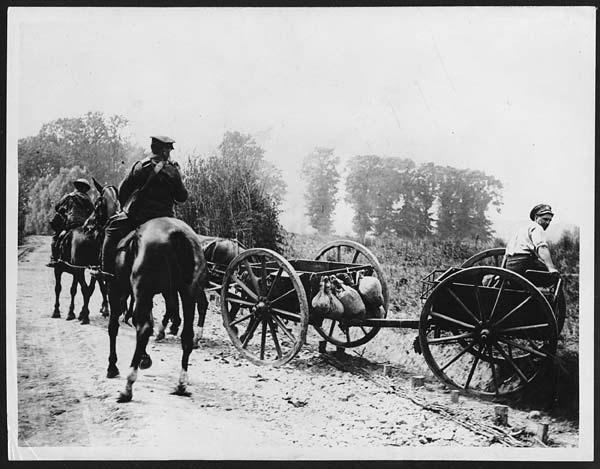Describe the objects in this image and their specific colors. I can see horse in black, darkgray, gray, and lightgray tones, people in black, gray, darkgray, and lightgray tones, horse in black, gray, darkgray, and lightgray tones, people in black, lightgray, darkgray, and gray tones, and horse in black, darkgray, gray, and lightgray tones in this image. 